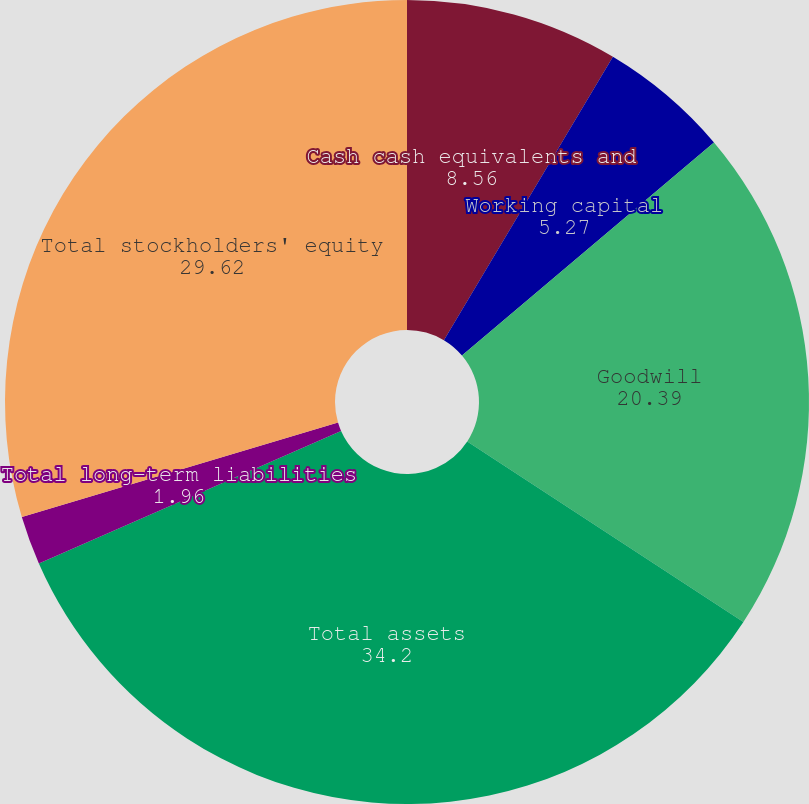Convert chart. <chart><loc_0><loc_0><loc_500><loc_500><pie_chart><fcel>Cash cash equivalents and<fcel>Working capital<fcel>Goodwill<fcel>Total assets<fcel>Total long-term liabilities<fcel>Total stockholders' equity<nl><fcel>8.56%<fcel>5.27%<fcel>20.39%<fcel>34.2%<fcel>1.96%<fcel>29.62%<nl></chart> 